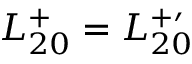Convert formula to latex. <formula><loc_0><loc_0><loc_500><loc_500>L _ { 2 0 } ^ { + } = L _ { 2 0 } ^ { + \prime }</formula> 